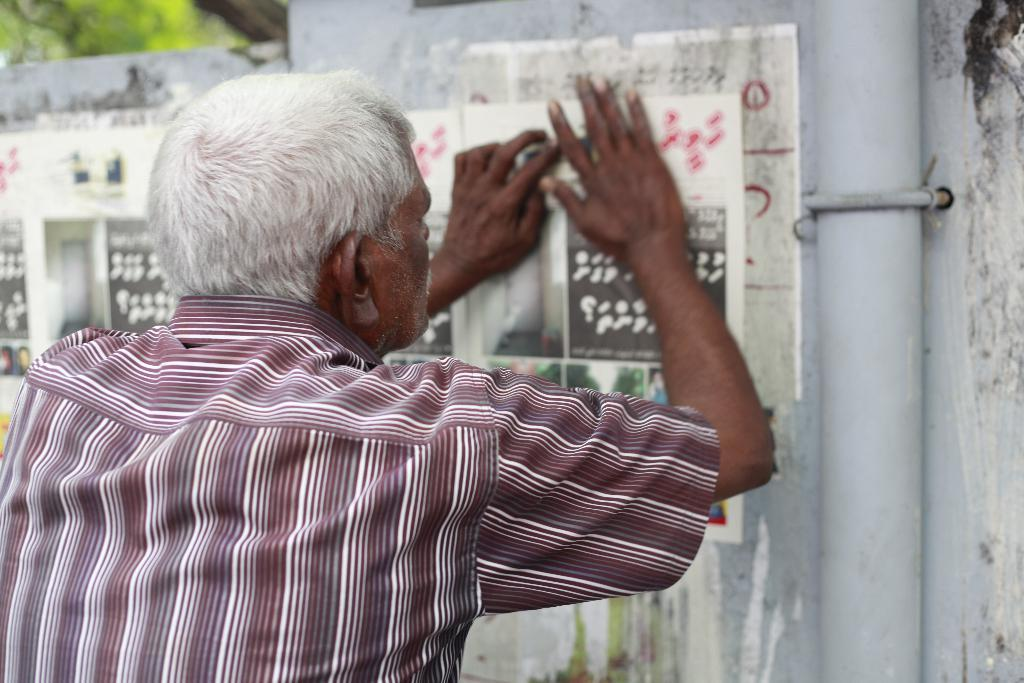Who is the main subject in the image? There is an old man in the image. What is the old man doing in the image? The old man is sticking posters on a white wall. What can be seen beside the old man? There is a pipe beside the old man. What is visible in the left top of the image? Trees are visible in the left top of the image. How are the trees depicted in the image? The trees are blurred. What type of committee is meeting in the image? There is no committee meeting in the image; it features an old man sticking posters on a wall. Can you tell me how many partners are visible in the image? There are no partners present in the image. 